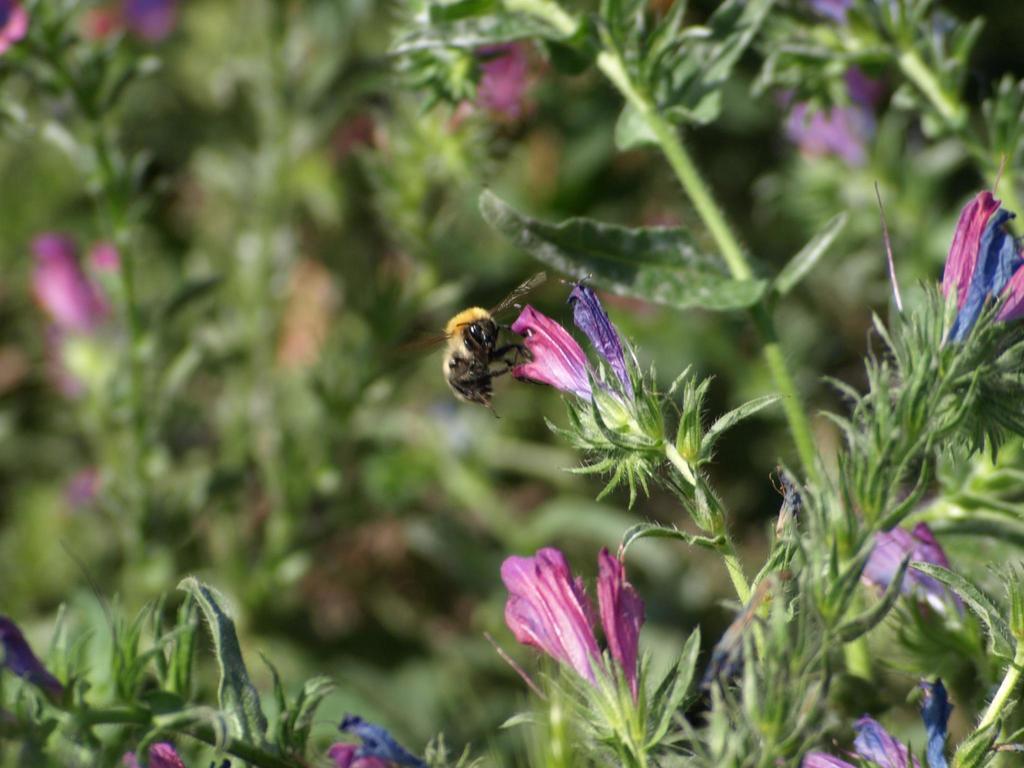How would you summarize this image in a sentence or two? In the picture we can see a plant with some flowers which are pink and violet in color and on the flower we can see a bee with wings and behind the plant we can see some plants which are not clearly visible. 